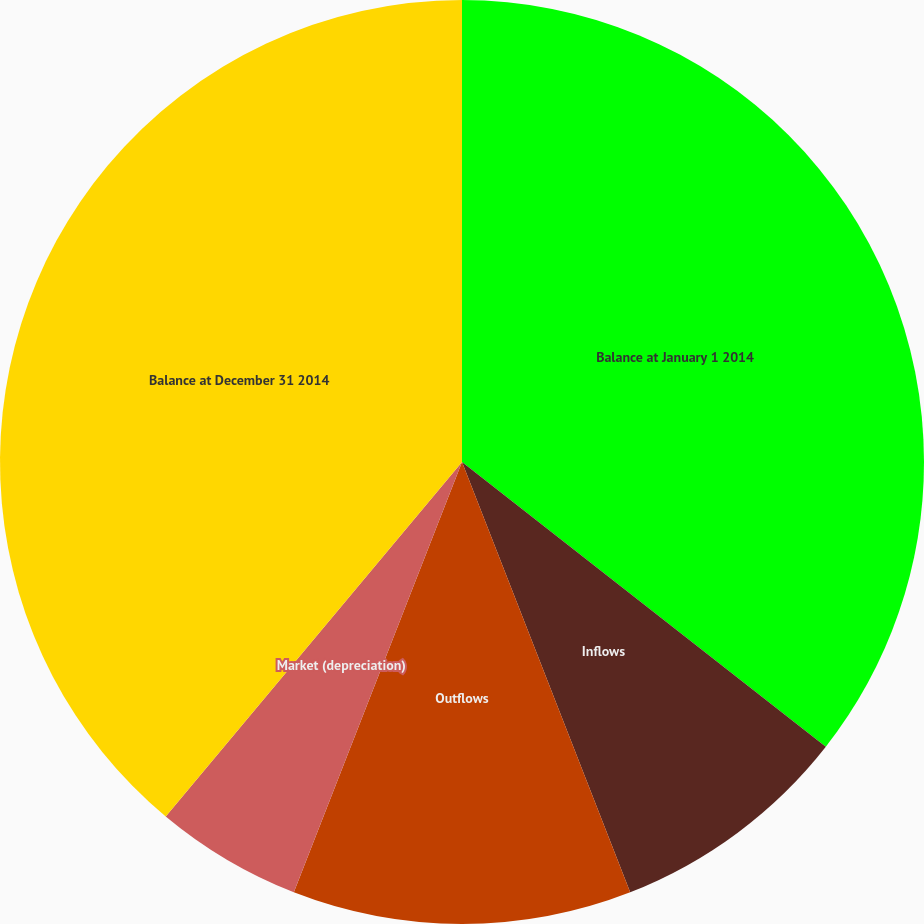Convert chart. <chart><loc_0><loc_0><loc_500><loc_500><pie_chart><fcel>Balance at January 1 2014<fcel>Inflows<fcel>Outflows<fcel>Market (depreciation)<fcel>Balance at December 31 2014<nl><fcel>35.57%<fcel>8.5%<fcel>11.86%<fcel>5.15%<fcel>38.92%<nl></chart> 